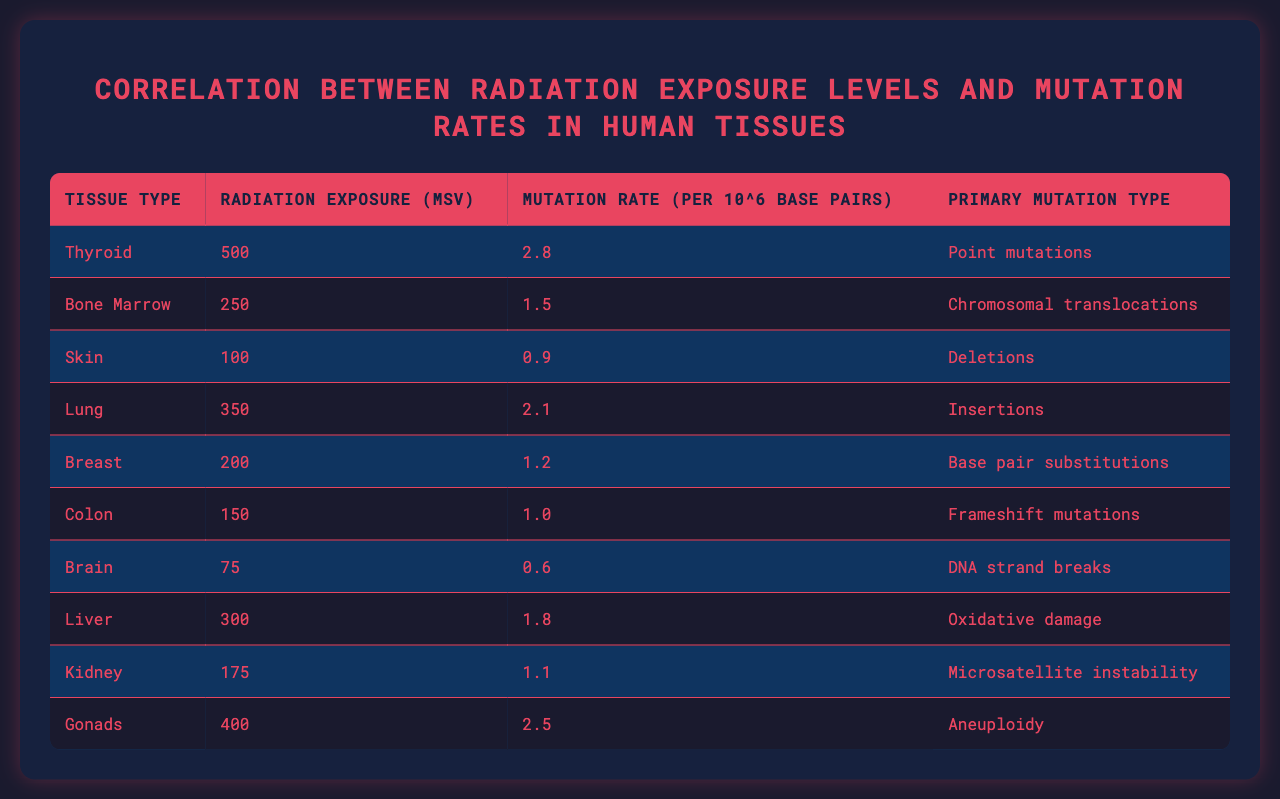What is the mutation rate for the Thyroid tissue? According to the table, the mutation rate listed for the Thyroid tissue is 2.8 per 10^6 base pairs.
Answer: 2.8 Which tissue type shows the highest radiation exposure? The table indicates that the Gonads have the highest radiation exposure level at 400 mSv.
Answer: 400 mSv What is the primary mutation type for Bone Marrow? Referring to the table, the primary mutation type associated with Bone Marrow is chromosomal translocations.
Answer: Chromosomal translocations Is the mutation rate of Skin tissue higher than that of Kidney tissue? By comparing the values, the mutation rate for Skin is 0.9, while Kidney is 1.1. Therefore, the mutation rate for Skin is not higher than that of Kidney.
Answer: No Calculate the average radiation exposure level across all tissues. The total radiation exposure for all tissues is 500 + 250 + 100 + 350 + 200 + 150 + 75 + 300 + 175 + 400 = 2100 mSv. There are 10 tissue types, so the average is 2100 mSv / 10 = 210 mSv.
Answer: 210 mSv Which mutation type has the lowest associated mutation rate? The mutation rates listed are 2.8, 1.5, 0.9, 2.1, 1.2, 1.0, 0.6, 1.8, 1.1, and 2.5 per 10^6 base pairs. The lowest mutation rate is 0.6 per 10^6 base pairs for Brain tissue.
Answer: 0.6 Is there a correlation between higher radiation exposure and higher mutation rates in this data set? By reviewing the table, we can observe that tissues with higher radiation exposure frequencies, such as Thyroid and Gonads, do show higher mutation rates, though a comprehensive analysis would require statistical measures.
Answer: Yes (observational correlation) What is the total number of mutation rates that are categorized as point mutations? Looking at the table, only the Thyroid tissue is identified under primary mutation type as point mutations; thus, the total count is 1.
Answer: 1 How does the mutation rate for Liver compare with that of Lung? The mutation rate for Liver is 1.8 and for Lung it is 2.1. Comparing these rates shows that Lung has a higher mutation rate than Liver.
Answer: Lung has a higher mutation rate What is the median radiation exposure level among the tissues? Listing the radiation exposure levels: 75, 100, 150, 175, 200, 250, 300, 350, 400, 500 mSv, and sorting them gives 75, 100, 150, 175, 200, 250, 300, 350, 400, 500. The median is the average of the 5th and 6th values, which is (200 + 250) / 2 = 225 mSv.
Answer: 225 mSv 